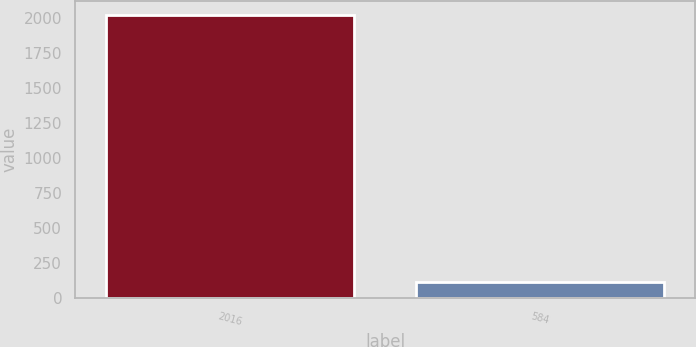Convert chart. <chart><loc_0><loc_0><loc_500><loc_500><bar_chart><fcel>2016<fcel>584<nl><fcel>2015<fcel>113.9<nl></chart> 